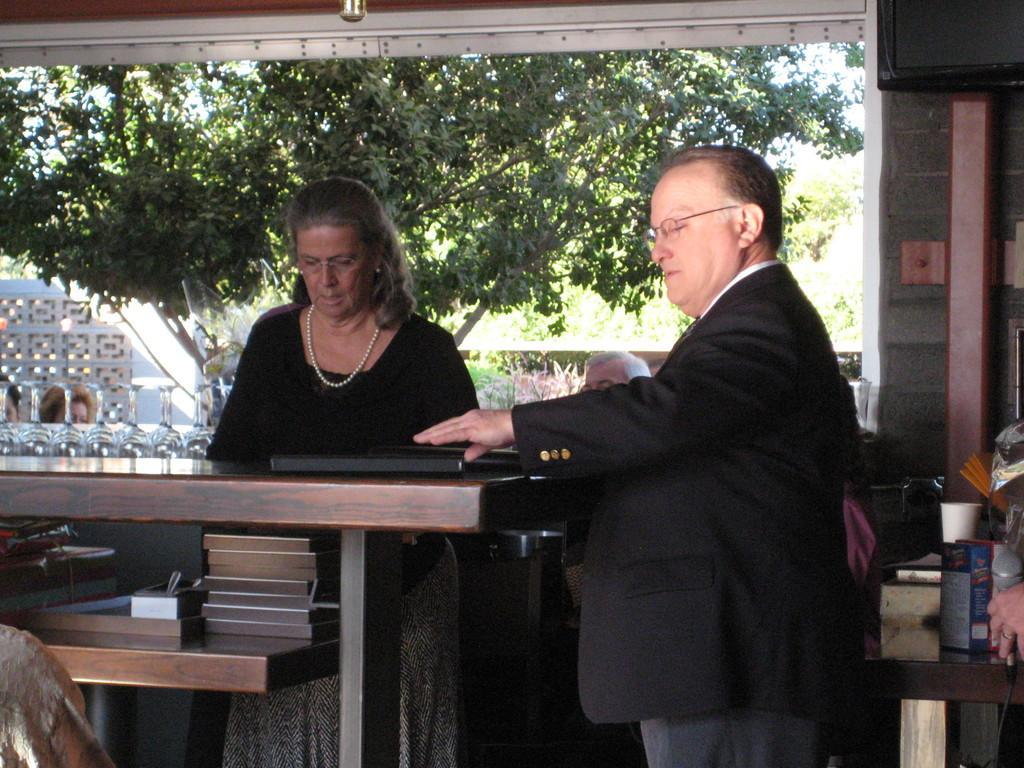Can you describe this image briefly? a person is standing at the center. left to him is a woman, standing. behind them there are trees. 